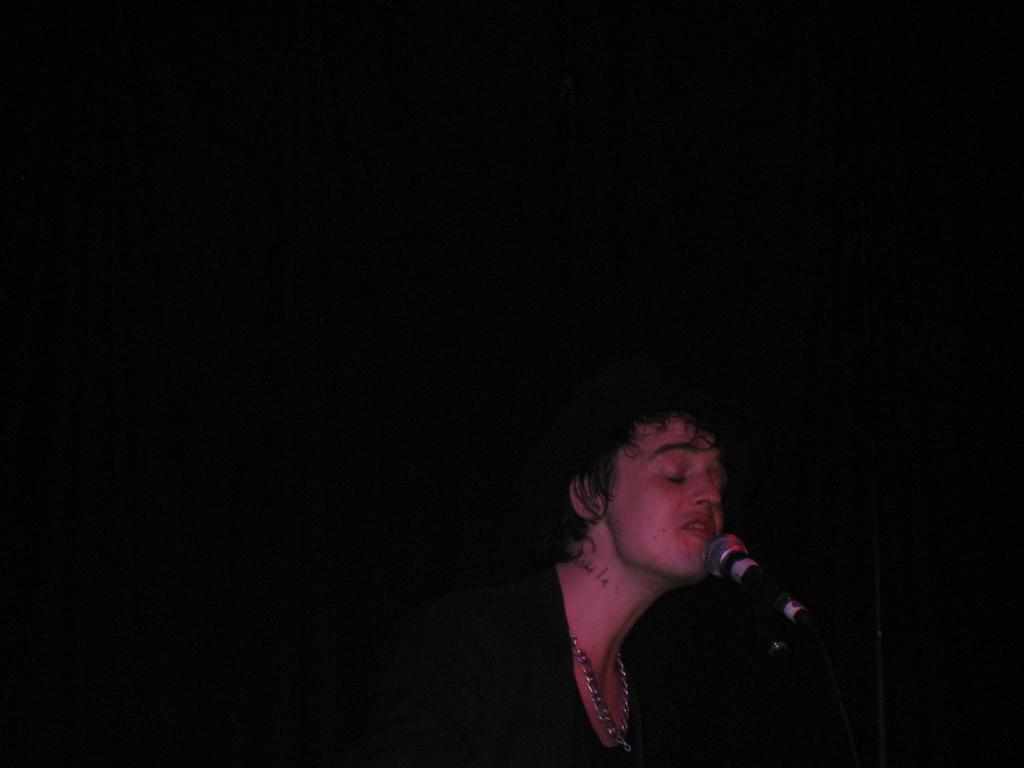Can you describe this image briefly? In this image I can see a person in front of mike. The background is dark in color. It looks as if the image is taken may be during night. 